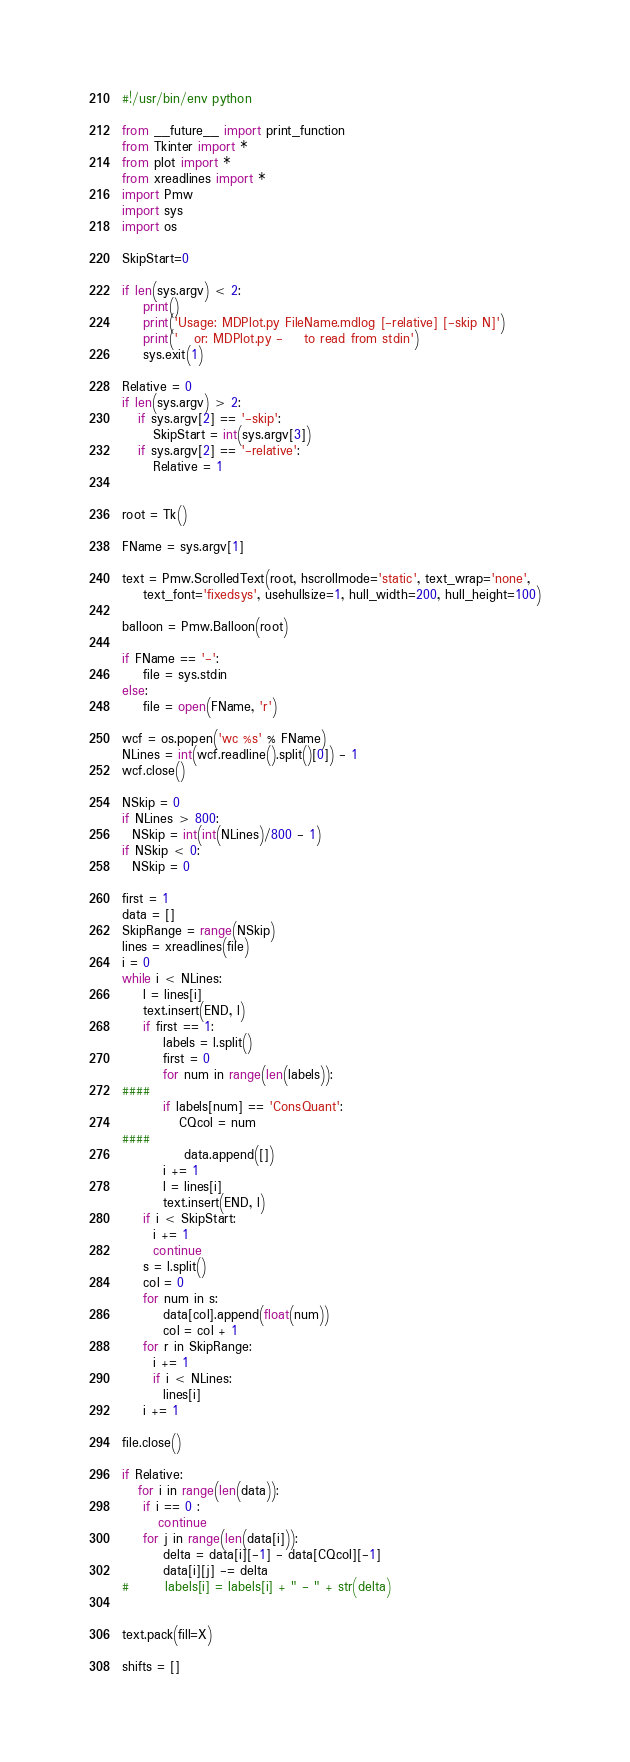Convert code to text. <code><loc_0><loc_0><loc_500><loc_500><_Python_>#!/usr/bin/env python

from __future__ import print_function
from Tkinter import *
from plot import *
from xreadlines import *
import Pmw
import sys
import os

SkipStart=0

if len(sys.argv) < 2:
    print()
    print('Usage: MDPlot.py FileName.mdlog [-relative] [-skip N]')
    print('   or: MDPlot.py -    to read from stdin')
    sys.exit(1)

Relative = 0
if len(sys.argv) > 2: 
   if sys.argv[2] == '-skip':
      SkipStart = int(sys.argv[3])
   if sys.argv[2] == '-relative':
      Relative = 1


root = Tk()

FName = sys.argv[1]

text = Pmw.ScrolledText(root, hscrollmode='static', text_wrap='none',
    text_font='fixedsys', usehullsize=1, hull_width=200, hull_height=100)

balloon = Pmw.Balloon(root)

if FName == '-':
    file = sys.stdin
else:
    file = open(FName, 'r')

wcf = os.popen('wc %s' % FName)
NLines = int(wcf.readline().split()[0]) - 1
wcf.close()

NSkip = 0
if NLines > 800:
  NSkip = int(int(NLines)/800 - 1)
if NSkip < 0:
  NSkip = 0

first = 1
data = []
SkipRange = range(NSkip)
lines = xreadlines(file)
i = 0
while i < NLines:
    l = lines[i]
    text.insert(END, l)
    if first == 1:
        labels = l.split()
        first = 0
        for num in range(len(labels)):
####
	    if labels[num] == 'ConsQuant':
	       CQcol = num
####
            data.append([])
        i += 1
        l = lines[i]
        text.insert(END, l)
    if i < SkipStart:
      i += 1
      continue
    s = l.split()
    col = 0
    for num in s:
        data[col].append(float(num))
        col = col + 1
    for r in SkipRange:
      i += 1
      if i < NLines:
        lines[i] 
    i += 1

file.close()

if Relative:
   for i in range(len(data)):
	if i == 0 :
	   continue
	for j in range(len(data[i])):
	    delta = data[i][-1] - data[CQcol][-1]
	    data[i][j] -= delta
#	    labels[i] = labels[i] + " - " + str(delta)


text.pack(fill=X)

shifts = []

</code> 